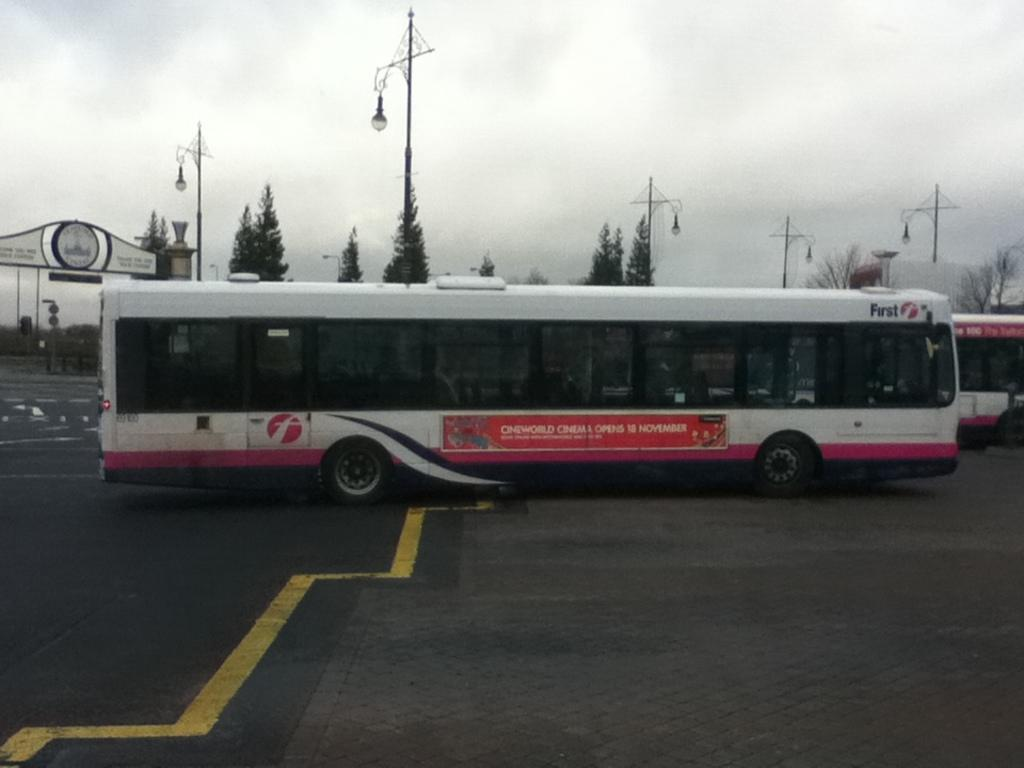What is the main subject in the center of the image? There is a bus in the center of the image. Where is the bus located? The bus is on the road. What can be seen in the background of the image? There are trees, light poles, and the sky visible in the background of the image. What is the condition of the sky in the image? The sky is visible in the background of the image, and there are clouds present. What type of jam is being used to grease the key in the image? There is no key or jam present in the image; it features a bus on the road with trees, light poles, and clouds in the background. 